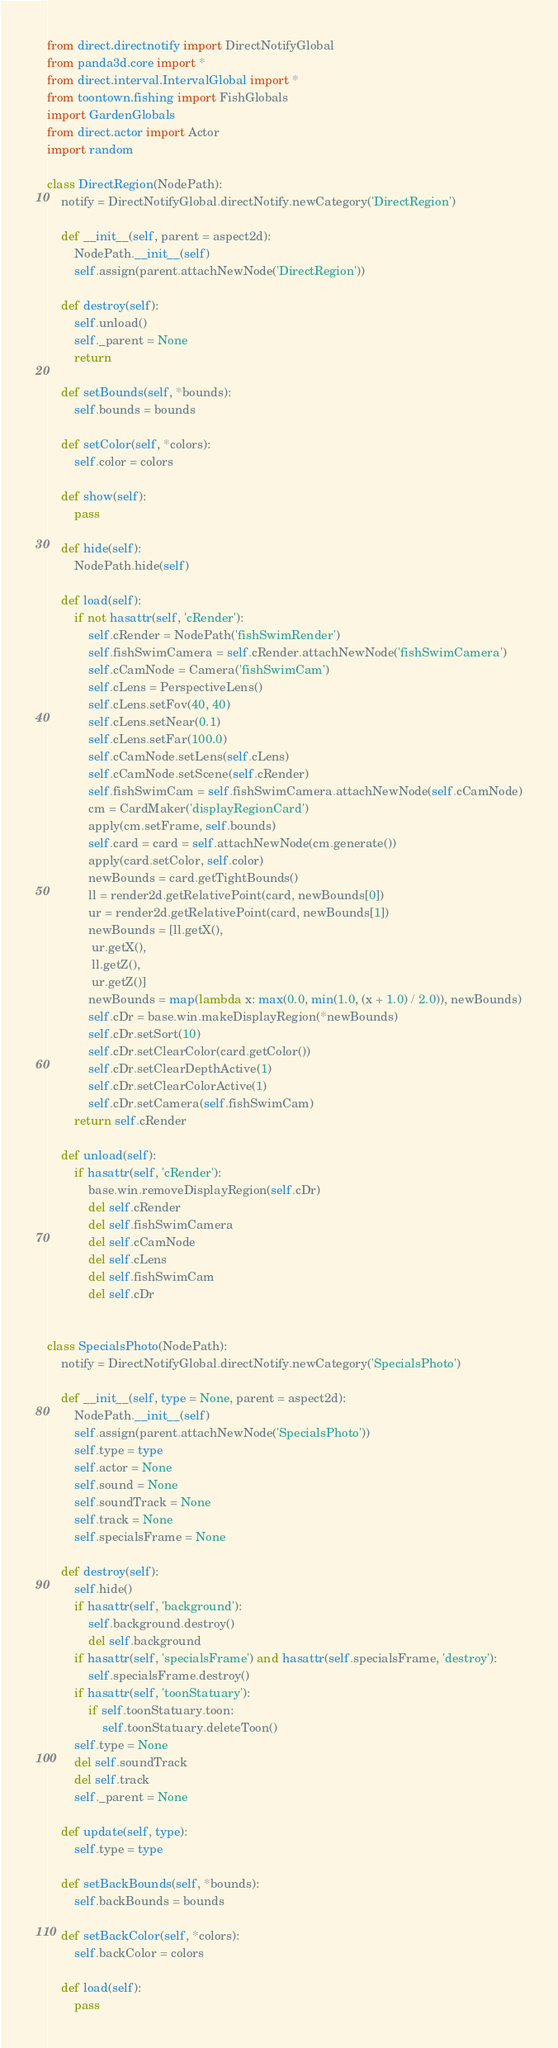Convert code to text. <code><loc_0><loc_0><loc_500><loc_500><_Python_>from direct.directnotify import DirectNotifyGlobal
from panda3d.core import *
from direct.interval.IntervalGlobal import *
from toontown.fishing import FishGlobals
import GardenGlobals
from direct.actor import Actor
import random

class DirectRegion(NodePath):
    notify = DirectNotifyGlobal.directNotify.newCategory('DirectRegion')

    def __init__(self, parent = aspect2d):
        NodePath.__init__(self)
        self.assign(parent.attachNewNode('DirectRegion'))

    def destroy(self):
        self.unload()
        self._parent = None
        return

    def setBounds(self, *bounds):
        self.bounds = bounds

    def setColor(self, *colors):
        self.color = colors

    def show(self):
        pass

    def hide(self):
        NodePath.hide(self)

    def load(self):
        if not hasattr(self, 'cRender'):
            self.cRender = NodePath('fishSwimRender')
            self.fishSwimCamera = self.cRender.attachNewNode('fishSwimCamera')
            self.cCamNode = Camera('fishSwimCam')
            self.cLens = PerspectiveLens()
            self.cLens.setFov(40, 40)
            self.cLens.setNear(0.1)
            self.cLens.setFar(100.0)
            self.cCamNode.setLens(self.cLens)
            self.cCamNode.setScene(self.cRender)
            self.fishSwimCam = self.fishSwimCamera.attachNewNode(self.cCamNode)
            cm = CardMaker('displayRegionCard')
            apply(cm.setFrame, self.bounds)
            self.card = card = self.attachNewNode(cm.generate())
            apply(card.setColor, self.color)
            newBounds = card.getTightBounds()
            ll = render2d.getRelativePoint(card, newBounds[0])
            ur = render2d.getRelativePoint(card, newBounds[1])
            newBounds = [ll.getX(),
             ur.getX(),
             ll.getZ(),
             ur.getZ()]
            newBounds = map(lambda x: max(0.0, min(1.0, (x + 1.0) / 2.0)), newBounds)
            self.cDr = base.win.makeDisplayRegion(*newBounds)
            self.cDr.setSort(10)
            self.cDr.setClearColor(card.getColor())
            self.cDr.setClearDepthActive(1)
            self.cDr.setClearColorActive(1)
            self.cDr.setCamera(self.fishSwimCam)
        return self.cRender

    def unload(self):
        if hasattr(self, 'cRender'):
            base.win.removeDisplayRegion(self.cDr)
            del self.cRender
            del self.fishSwimCamera
            del self.cCamNode
            del self.cLens
            del self.fishSwimCam
            del self.cDr


class SpecialsPhoto(NodePath):
    notify = DirectNotifyGlobal.directNotify.newCategory('SpecialsPhoto')

    def __init__(self, type = None, parent = aspect2d):
        NodePath.__init__(self)
        self.assign(parent.attachNewNode('SpecialsPhoto'))
        self.type = type
        self.actor = None
        self.sound = None
        self.soundTrack = None
        self.track = None
        self.specialsFrame = None

    def destroy(self):
        self.hide()
        if hasattr(self, 'background'):
            self.background.destroy()
            del self.background
        if hasattr(self, 'specialsFrame') and hasattr(self.specialsFrame, 'destroy'):
            self.specialsFrame.destroy()
        if hasattr(self, 'toonStatuary'):
            if self.toonStatuary.toon:
                self.toonStatuary.deleteToon()
        self.type = None
        del self.soundTrack
        del self.track
        self._parent = None

    def update(self, type):
        self.type = type

    def setBackBounds(self, *bounds):
        self.backBounds = bounds

    def setBackColor(self, *colors):
        self.backColor = colors

    def load(self):
        pass
</code> 